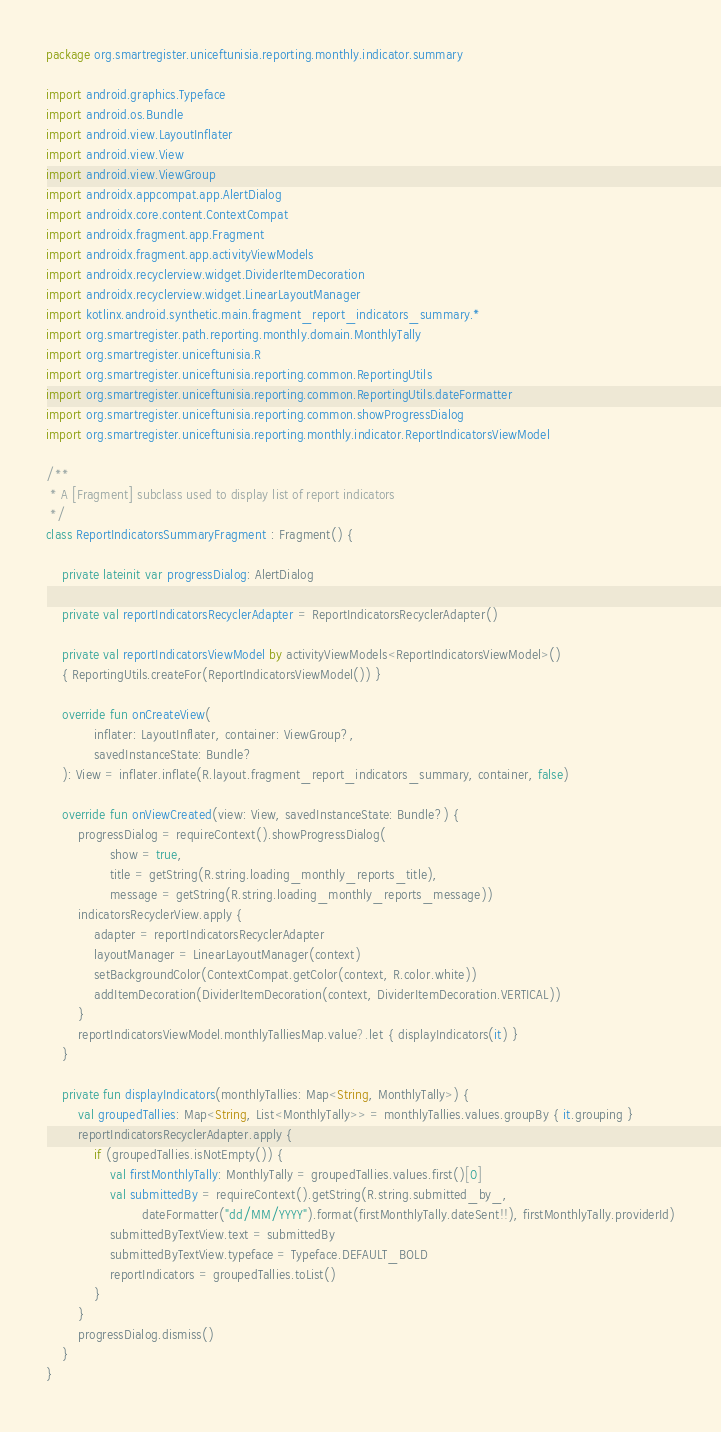<code> <loc_0><loc_0><loc_500><loc_500><_Kotlin_>package org.smartregister.uniceftunisia.reporting.monthly.indicator.summary

import android.graphics.Typeface
import android.os.Bundle
import android.view.LayoutInflater
import android.view.View
import android.view.ViewGroup
import androidx.appcompat.app.AlertDialog
import androidx.core.content.ContextCompat
import androidx.fragment.app.Fragment
import androidx.fragment.app.activityViewModels
import androidx.recyclerview.widget.DividerItemDecoration
import androidx.recyclerview.widget.LinearLayoutManager
import kotlinx.android.synthetic.main.fragment_report_indicators_summary.*
import org.smartregister.path.reporting.monthly.domain.MonthlyTally
import org.smartregister.uniceftunisia.R
import org.smartregister.uniceftunisia.reporting.common.ReportingUtils
import org.smartregister.uniceftunisia.reporting.common.ReportingUtils.dateFormatter
import org.smartregister.uniceftunisia.reporting.common.showProgressDialog
import org.smartregister.uniceftunisia.reporting.monthly.indicator.ReportIndicatorsViewModel

/**
 * A [Fragment] subclass used to display list of report indicators
 */
class ReportIndicatorsSummaryFragment : Fragment() {

    private lateinit var progressDialog: AlertDialog

    private val reportIndicatorsRecyclerAdapter = ReportIndicatorsRecyclerAdapter()

    private val reportIndicatorsViewModel by activityViewModels<ReportIndicatorsViewModel>()
    { ReportingUtils.createFor(ReportIndicatorsViewModel()) }

    override fun onCreateView(
            inflater: LayoutInflater, container: ViewGroup?,
            savedInstanceState: Bundle?
    ): View = inflater.inflate(R.layout.fragment_report_indicators_summary, container, false)

    override fun onViewCreated(view: View, savedInstanceState: Bundle?) {
        progressDialog = requireContext().showProgressDialog(
                show = true,
                title = getString(R.string.loading_monthly_reports_title),
                message = getString(R.string.loading_monthly_reports_message))
        indicatorsRecyclerView.apply {
            adapter = reportIndicatorsRecyclerAdapter
            layoutManager = LinearLayoutManager(context)
            setBackgroundColor(ContextCompat.getColor(context, R.color.white))
            addItemDecoration(DividerItemDecoration(context, DividerItemDecoration.VERTICAL))
        }
        reportIndicatorsViewModel.monthlyTalliesMap.value?.let { displayIndicators(it) }
    }

    private fun displayIndicators(monthlyTallies: Map<String, MonthlyTally>) {
        val groupedTallies: Map<String, List<MonthlyTally>> = monthlyTallies.values.groupBy { it.grouping }
        reportIndicatorsRecyclerAdapter.apply {
            if (groupedTallies.isNotEmpty()) {
                val firstMonthlyTally: MonthlyTally = groupedTallies.values.first()[0]
                val submittedBy = requireContext().getString(R.string.submitted_by_,
                        dateFormatter("dd/MM/YYYY").format(firstMonthlyTally.dateSent!!), firstMonthlyTally.providerId)
                submittedByTextView.text = submittedBy
                submittedByTextView.typeface = Typeface.DEFAULT_BOLD
                reportIndicators = groupedTallies.toList()
            }
        }
        progressDialog.dismiss()
    }
}</code> 